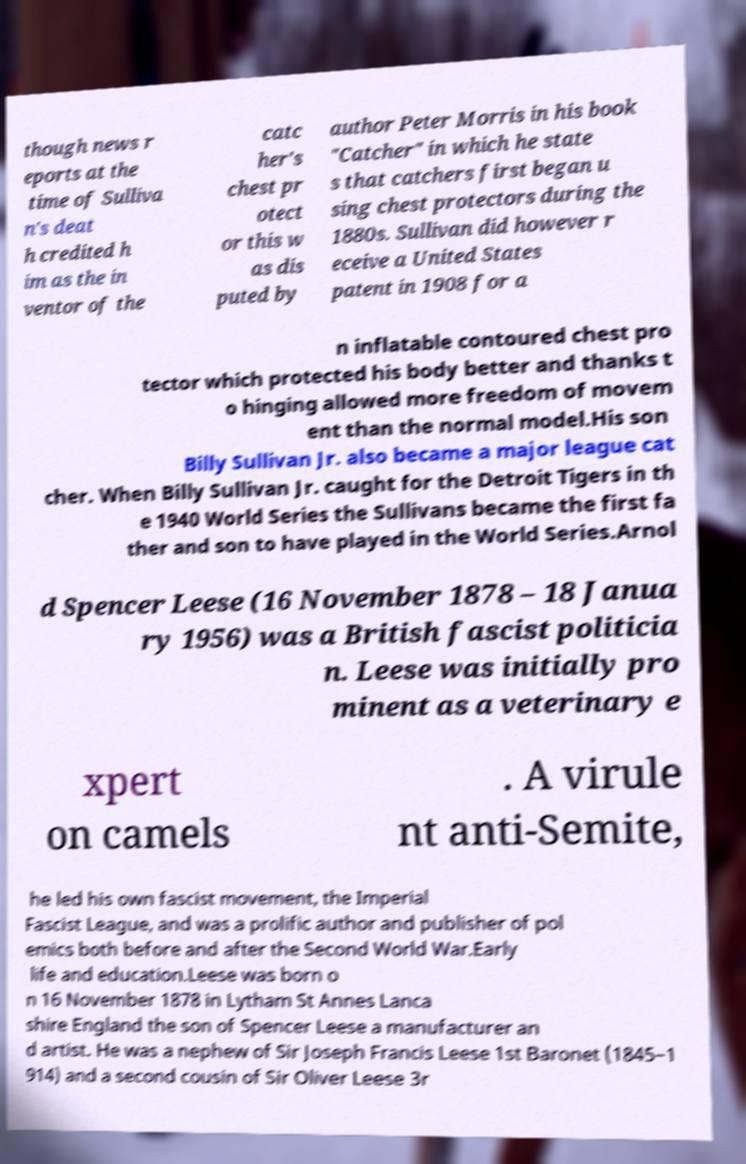Could you extract and type out the text from this image? though news r eports at the time of Sulliva n's deat h credited h im as the in ventor of the catc her's chest pr otect or this w as dis puted by author Peter Morris in his book "Catcher" in which he state s that catchers first began u sing chest protectors during the 1880s. Sullivan did however r eceive a United States patent in 1908 for a n inflatable contoured chest pro tector which protected his body better and thanks t o hinging allowed more freedom of movem ent than the normal model.His son Billy Sullivan Jr. also became a major league cat cher. When Billy Sullivan Jr. caught for the Detroit Tigers in th e 1940 World Series the Sullivans became the first fa ther and son to have played in the World Series.Arnol d Spencer Leese (16 November 1878 – 18 Janua ry 1956) was a British fascist politicia n. Leese was initially pro minent as a veterinary e xpert on camels . A virule nt anti-Semite, he led his own fascist movement, the Imperial Fascist League, and was a prolific author and publisher of pol emics both before and after the Second World War.Early life and education.Leese was born o n 16 November 1878 in Lytham St Annes Lanca shire England the son of Spencer Leese a manufacturer an d artist. He was a nephew of Sir Joseph Francis Leese 1st Baronet (1845–1 914) and a second cousin of Sir Oliver Leese 3r 